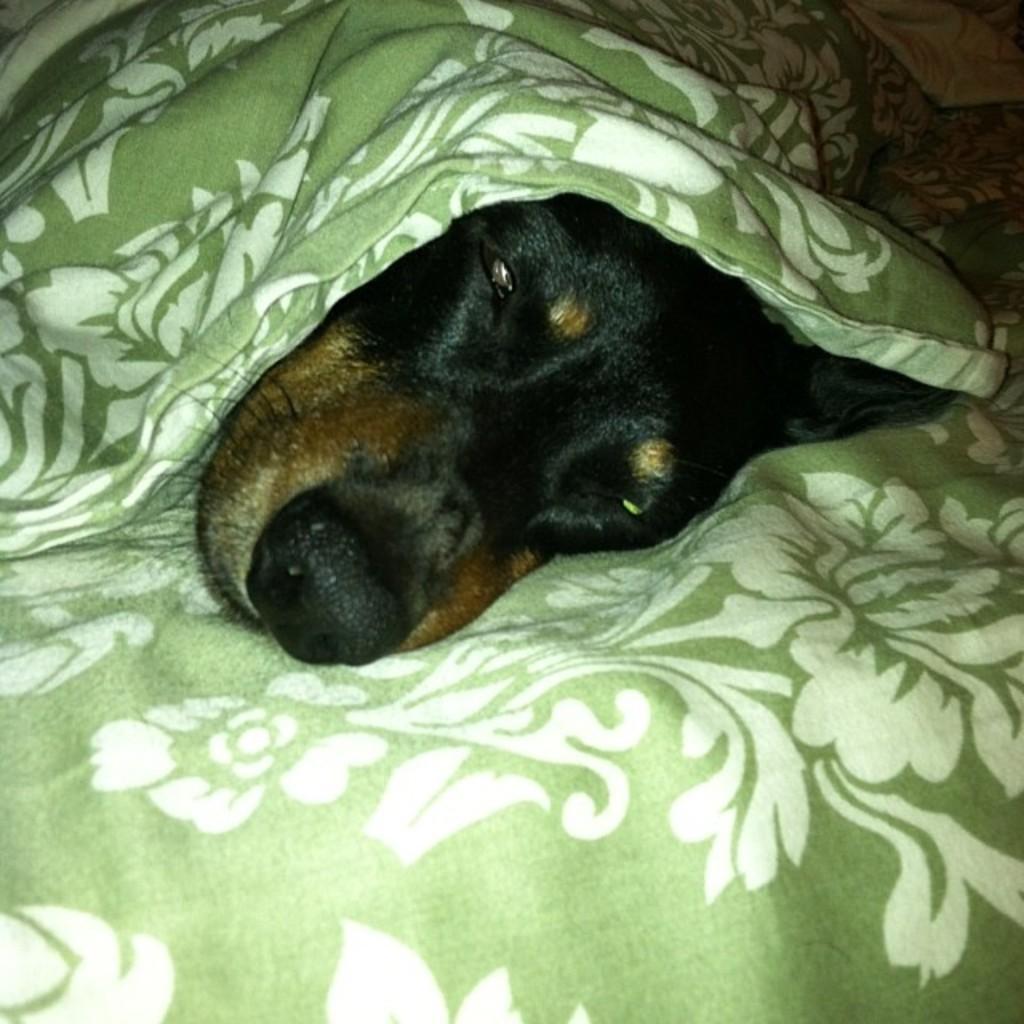Could you give a brief overview of what you see in this image? In this image there is a dog laying on the blanket of the bed , with a blanket on it. 